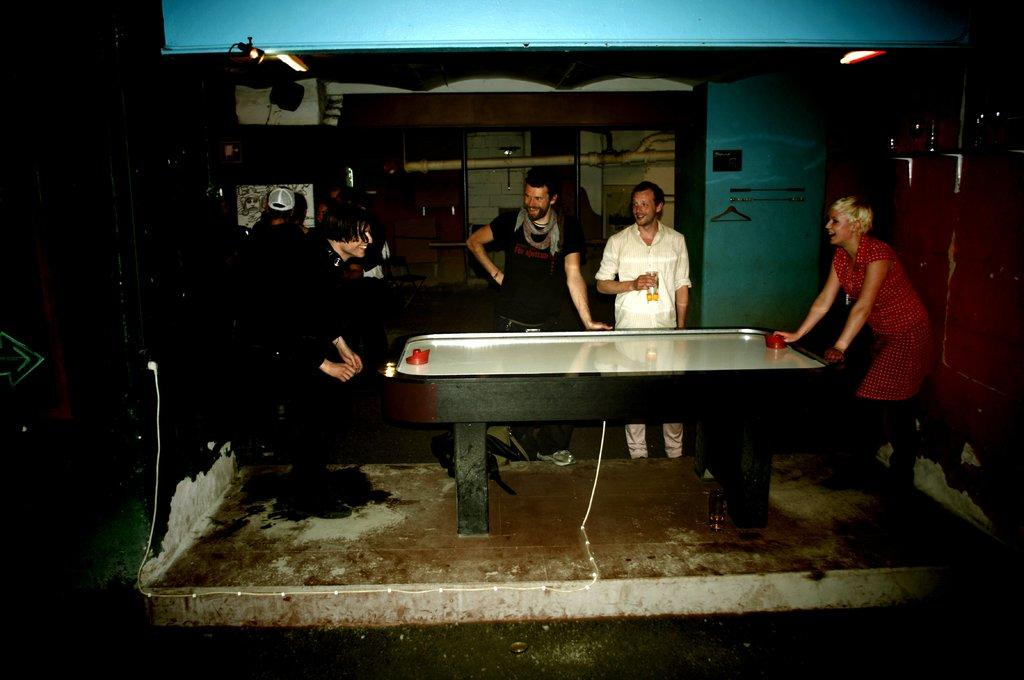Who is present in the image? There are people in the image. What are the people doing in the image? The people are around a table and playing a game. Can you describe the lighting in the image? There is a light in the image. What can be seen on the wall in the image? There are objects on the wall. What type of skin condition can be seen on the people in the image? There is no indication of any skin condition on the people in the image. How many birds are flying in the image? There are no birds present in the image. 